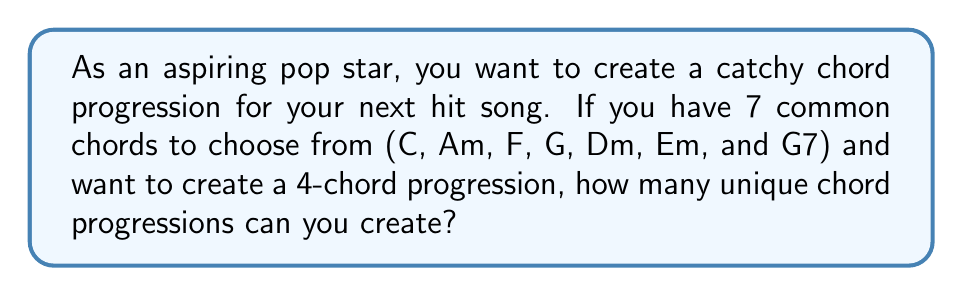Can you solve this math problem? Let's approach this step-by-step:

1) This is a problem of permutation with repetition. We are selecting 4 chords from a set of 7 chords, and the order matters (since the sequence of chords affects the sound of the progression).

2) In permutation with repetition, we can use the same item (in this case, chord) more than once, and the formula is:

   $$ n^r $$

   Where $n$ is the number of items to choose from, and $r$ is the number of selections.

3) In this case:
   $n = 7$ (the number of chords to choose from)
   $r = 4$ (the length of the chord progression)

4) Plugging these values into our formula:

   $$ 7^4 $$

5) Calculating this:

   $$ 7^4 = 7 \times 7 \times 7 \times 7 = 2401 $$

Therefore, you can create 2401 unique 4-chord progressions using these 7 chords.
Answer: 2401 